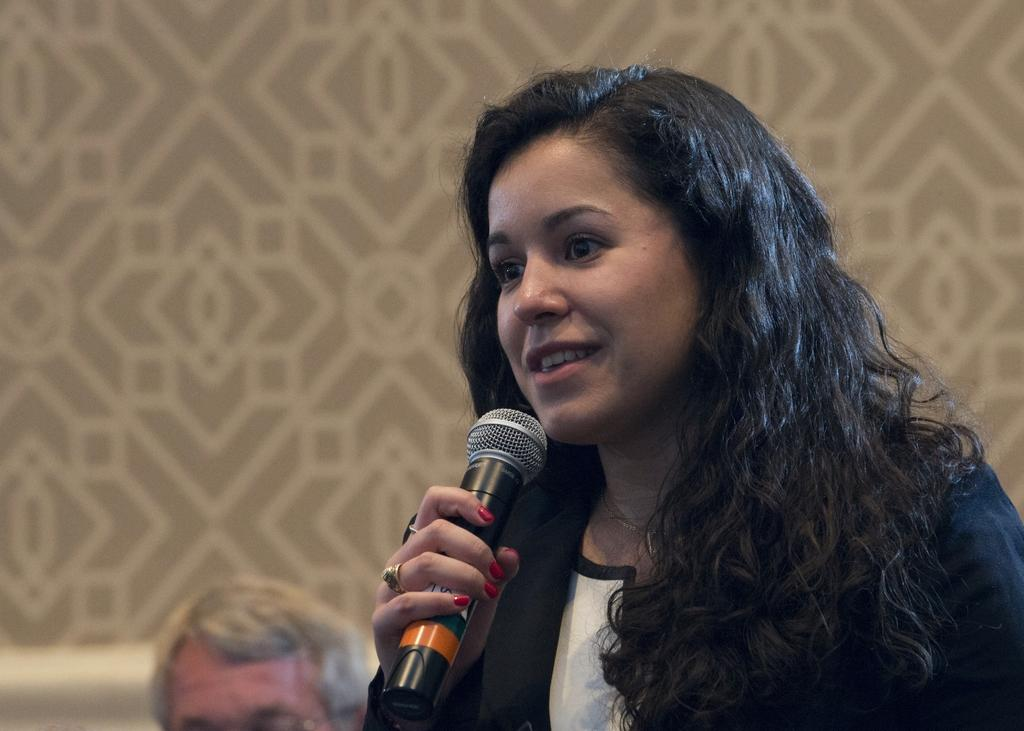Who is the main subject in the image? There is a woman in the image. Where is the woman located in the image? The woman is on the right side of the image. What is the woman holding in the image? The woman is holding a mic. What is the woman doing in the image? The woman's mouth is open, suggesting she is speaking. Can you describe anything in the background of the image? There is another person's head visible in the background, and there is a painting on the wall in the background. What type of thunder can be heard in the image? There is no thunder present in the image; it is a still image with no sound. 